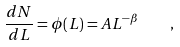<formula> <loc_0><loc_0><loc_500><loc_500>\frac { d N } { d L } = \phi ( L ) = A L ^ { - \beta } \quad ,</formula> 